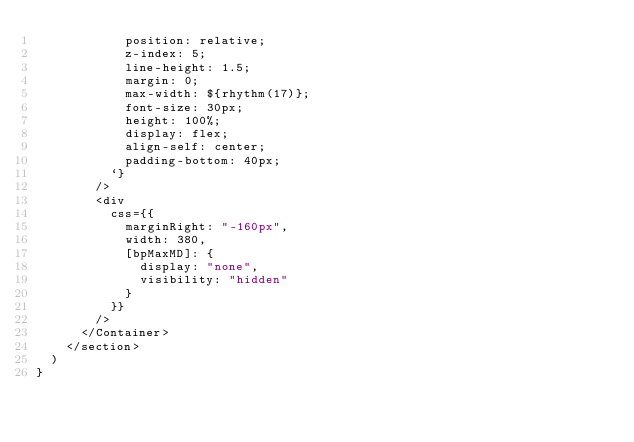<code> <loc_0><loc_0><loc_500><loc_500><_TypeScript_>            position: relative;
            z-index: 5;
            line-height: 1.5;
            margin: 0;
            max-width: ${rhythm(17)};
            font-size: 30px;
            height: 100%;
            display: flex;
            align-self: center;
            padding-bottom: 40px;
          `}
        />
        <div
          css={{
            marginRight: "-160px",
            width: 380,
            [bpMaxMD]: {
              display: "none",
              visibility: "hidden"
            }
          }}
        />
      </Container>
    </section>
  )
}
</code> 